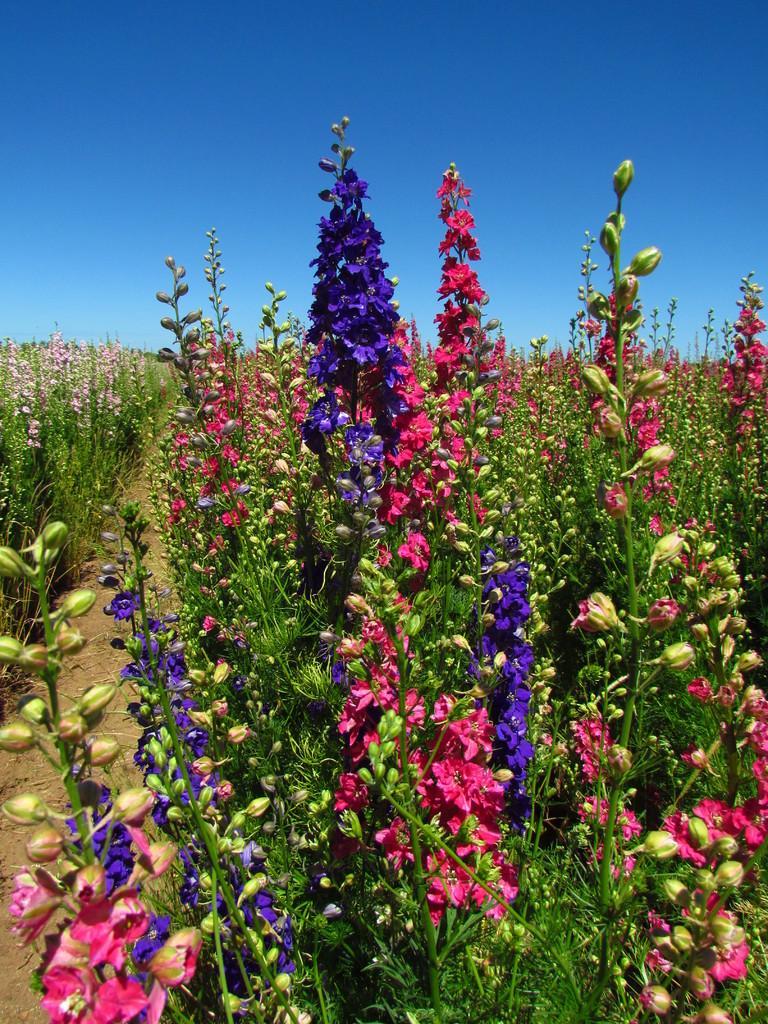Please provide a concise description of this image. We can see plants, flowers and buds. In the background we can see sky in blue color. 